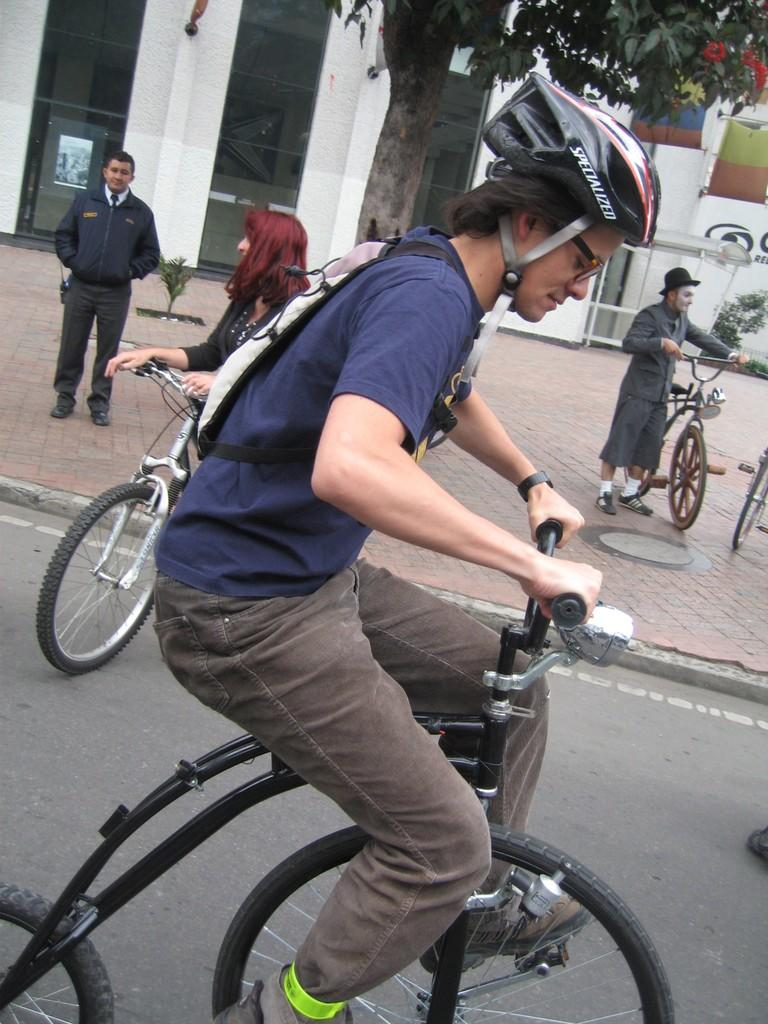What is the man in the image doing? The man is riding a bicycle in the image. What is the man wearing while riding the bicycle? The man is wearing a bag in the image. What can be seen in the background of the image? There is a building and a tree in the background of the image. Are there any other people in the image? Yes, there are people in the background of the image, and they are holding bicycles. What type of pest can be seen crawling on the floor in the image? There is no pest visible on the floor in the image. 